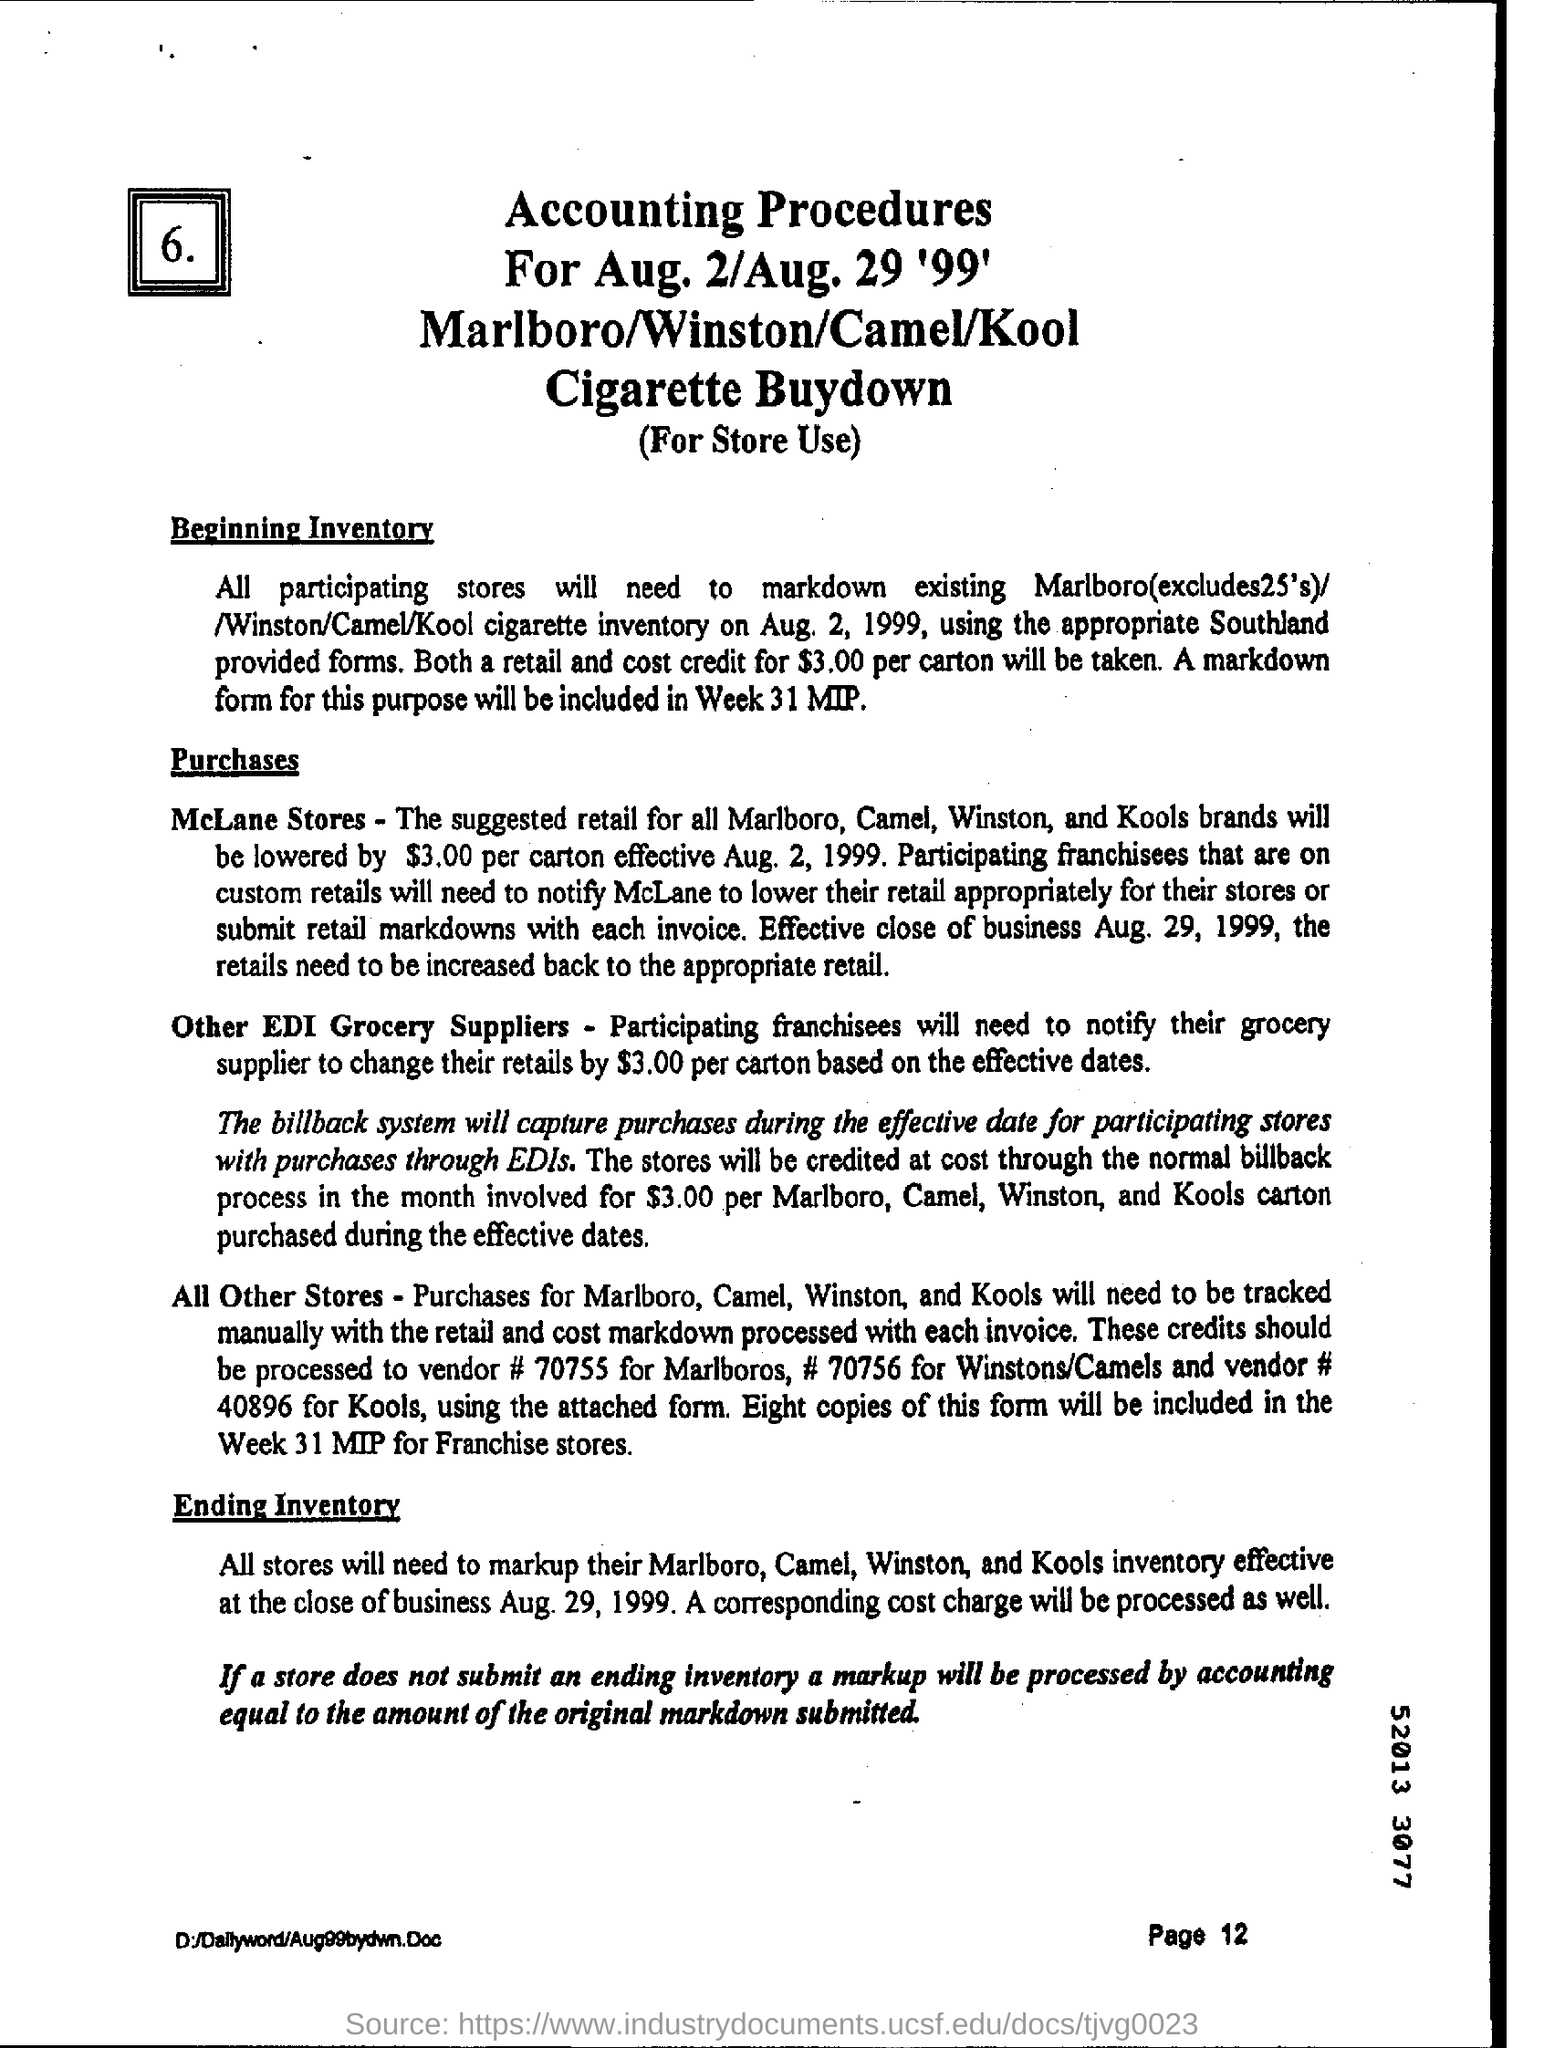Mention a couple of crucial points in this snapshot. The page number written on the bottom is 12. 